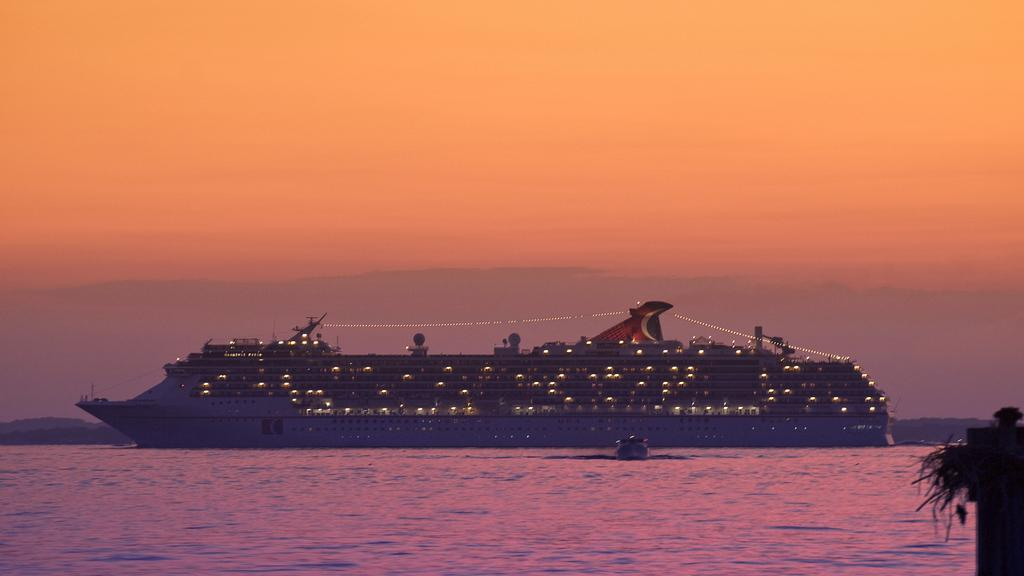What type of watercraft can be seen in the image? There is a ship and a boat in the image. Where are the ship and boat located? Both the ship and boat are on the water. What can be seen in the background of the image? There are hills and the sky visible in the background of the image. What type of silk fabric is draped over the ship in the image? There is no silk fabric present in the image; it only features a ship and a boat on the water. 